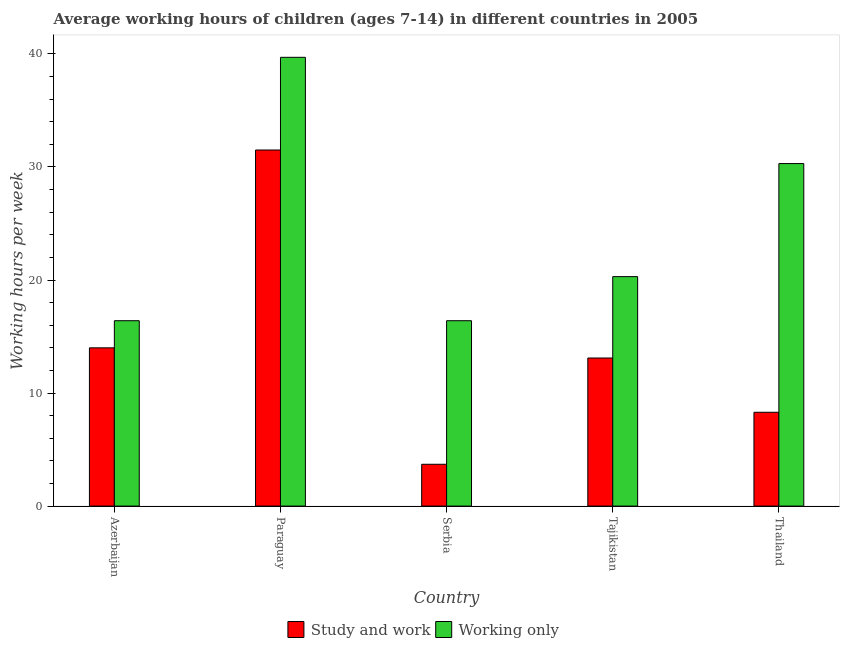Are the number of bars on each tick of the X-axis equal?
Give a very brief answer. Yes. What is the label of the 2nd group of bars from the left?
Make the answer very short. Paraguay. In how many cases, is the number of bars for a given country not equal to the number of legend labels?
Your answer should be compact. 0. What is the average working hour of children involved in study and work in Thailand?
Offer a terse response. 8.3. Across all countries, what is the maximum average working hour of children involved in only work?
Keep it short and to the point. 39.7. Across all countries, what is the minimum average working hour of children involved in only work?
Your response must be concise. 16.4. In which country was the average working hour of children involved in study and work maximum?
Offer a terse response. Paraguay. In which country was the average working hour of children involved in study and work minimum?
Provide a short and direct response. Serbia. What is the total average working hour of children involved in study and work in the graph?
Give a very brief answer. 70.6. What is the difference between the average working hour of children involved in only work in Paraguay and that in Tajikistan?
Your answer should be compact. 19.4. What is the difference between the average working hour of children involved in only work in Thailand and the average working hour of children involved in study and work in Serbia?
Keep it short and to the point. 26.6. What is the average average working hour of children involved in study and work per country?
Ensure brevity in your answer.  14.12. What is the difference between the average working hour of children involved in study and work and average working hour of children involved in only work in Thailand?
Make the answer very short. -22. What is the ratio of the average working hour of children involved in study and work in Tajikistan to that in Thailand?
Ensure brevity in your answer.  1.58. Is the average working hour of children involved in study and work in Serbia less than that in Tajikistan?
Provide a short and direct response. Yes. What is the difference between the highest and the second highest average working hour of children involved in study and work?
Your response must be concise. 17.5. What is the difference between the highest and the lowest average working hour of children involved in only work?
Provide a short and direct response. 23.3. In how many countries, is the average working hour of children involved in study and work greater than the average average working hour of children involved in study and work taken over all countries?
Give a very brief answer. 1. What does the 1st bar from the left in Azerbaijan represents?
Ensure brevity in your answer.  Study and work. What does the 1st bar from the right in Thailand represents?
Provide a short and direct response. Working only. What is the difference between two consecutive major ticks on the Y-axis?
Your answer should be very brief. 10. Does the graph contain grids?
Your answer should be very brief. No. How are the legend labels stacked?
Provide a succinct answer. Horizontal. What is the title of the graph?
Give a very brief answer. Average working hours of children (ages 7-14) in different countries in 2005. What is the label or title of the Y-axis?
Offer a terse response. Working hours per week. What is the Working hours per week in Study and work in Paraguay?
Make the answer very short. 31.5. What is the Working hours per week in Working only in Paraguay?
Provide a short and direct response. 39.7. What is the Working hours per week in Study and work in Serbia?
Make the answer very short. 3.7. What is the Working hours per week in Working only in Tajikistan?
Keep it short and to the point. 20.3. What is the Working hours per week of Study and work in Thailand?
Make the answer very short. 8.3. What is the Working hours per week of Working only in Thailand?
Your answer should be compact. 30.3. Across all countries, what is the maximum Working hours per week of Study and work?
Ensure brevity in your answer.  31.5. Across all countries, what is the maximum Working hours per week of Working only?
Give a very brief answer. 39.7. Across all countries, what is the minimum Working hours per week in Working only?
Make the answer very short. 16.4. What is the total Working hours per week in Study and work in the graph?
Give a very brief answer. 70.6. What is the total Working hours per week in Working only in the graph?
Provide a succinct answer. 123.1. What is the difference between the Working hours per week of Study and work in Azerbaijan and that in Paraguay?
Keep it short and to the point. -17.5. What is the difference between the Working hours per week in Working only in Azerbaijan and that in Paraguay?
Provide a short and direct response. -23.3. What is the difference between the Working hours per week of Study and work in Azerbaijan and that in Serbia?
Your response must be concise. 10.3. What is the difference between the Working hours per week in Working only in Azerbaijan and that in Serbia?
Keep it short and to the point. 0. What is the difference between the Working hours per week of Study and work in Azerbaijan and that in Tajikistan?
Offer a very short reply. 0.9. What is the difference between the Working hours per week of Working only in Azerbaijan and that in Tajikistan?
Your answer should be compact. -3.9. What is the difference between the Working hours per week of Study and work in Azerbaijan and that in Thailand?
Your response must be concise. 5.7. What is the difference between the Working hours per week in Working only in Azerbaijan and that in Thailand?
Keep it short and to the point. -13.9. What is the difference between the Working hours per week of Study and work in Paraguay and that in Serbia?
Offer a very short reply. 27.8. What is the difference between the Working hours per week of Working only in Paraguay and that in Serbia?
Make the answer very short. 23.3. What is the difference between the Working hours per week of Study and work in Paraguay and that in Tajikistan?
Make the answer very short. 18.4. What is the difference between the Working hours per week in Study and work in Paraguay and that in Thailand?
Make the answer very short. 23.2. What is the difference between the Working hours per week in Working only in Paraguay and that in Thailand?
Ensure brevity in your answer.  9.4. What is the difference between the Working hours per week in Study and work in Serbia and that in Tajikistan?
Provide a succinct answer. -9.4. What is the difference between the Working hours per week of Working only in Serbia and that in Tajikistan?
Offer a very short reply. -3.9. What is the difference between the Working hours per week of Study and work in Serbia and that in Thailand?
Offer a very short reply. -4.6. What is the difference between the Working hours per week of Working only in Serbia and that in Thailand?
Ensure brevity in your answer.  -13.9. What is the difference between the Working hours per week in Study and work in Tajikistan and that in Thailand?
Your answer should be very brief. 4.8. What is the difference between the Working hours per week in Working only in Tajikistan and that in Thailand?
Give a very brief answer. -10. What is the difference between the Working hours per week of Study and work in Azerbaijan and the Working hours per week of Working only in Paraguay?
Your answer should be very brief. -25.7. What is the difference between the Working hours per week of Study and work in Azerbaijan and the Working hours per week of Working only in Serbia?
Provide a succinct answer. -2.4. What is the difference between the Working hours per week in Study and work in Azerbaijan and the Working hours per week in Working only in Thailand?
Provide a short and direct response. -16.3. What is the difference between the Working hours per week of Study and work in Paraguay and the Working hours per week of Working only in Serbia?
Make the answer very short. 15.1. What is the difference between the Working hours per week in Study and work in Paraguay and the Working hours per week in Working only in Thailand?
Your response must be concise. 1.2. What is the difference between the Working hours per week of Study and work in Serbia and the Working hours per week of Working only in Tajikistan?
Ensure brevity in your answer.  -16.6. What is the difference between the Working hours per week of Study and work in Serbia and the Working hours per week of Working only in Thailand?
Offer a terse response. -26.6. What is the difference between the Working hours per week of Study and work in Tajikistan and the Working hours per week of Working only in Thailand?
Your answer should be compact. -17.2. What is the average Working hours per week of Study and work per country?
Your answer should be very brief. 14.12. What is the average Working hours per week in Working only per country?
Provide a short and direct response. 24.62. What is the difference between the Working hours per week of Study and work and Working hours per week of Working only in Azerbaijan?
Keep it short and to the point. -2.4. What is the difference between the Working hours per week in Study and work and Working hours per week in Working only in Paraguay?
Your answer should be very brief. -8.2. What is the difference between the Working hours per week in Study and work and Working hours per week in Working only in Tajikistan?
Provide a short and direct response. -7.2. What is the ratio of the Working hours per week in Study and work in Azerbaijan to that in Paraguay?
Offer a very short reply. 0.44. What is the ratio of the Working hours per week of Working only in Azerbaijan to that in Paraguay?
Offer a very short reply. 0.41. What is the ratio of the Working hours per week of Study and work in Azerbaijan to that in Serbia?
Offer a very short reply. 3.78. What is the ratio of the Working hours per week of Study and work in Azerbaijan to that in Tajikistan?
Provide a succinct answer. 1.07. What is the ratio of the Working hours per week in Working only in Azerbaijan to that in Tajikistan?
Provide a short and direct response. 0.81. What is the ratio of the Working hours per week in Study and work in Azerbaijan to that in Thailand?
Provide a short and direct response. 1.69. What is the ratio of the Working hours per week in Working only in Azerbaijan to that in Thailand?
Ensure brevity in your answer.  0.54. What is the ratio of the Working hours per week of Study and work in Paraguay to that in Serbia?
Your answer should be very brief. 8.51. What is the ratio of the Working hours per week of Working only in Paraguay to that in Serbia?
Your response must be concise. 2.42. What is the ratio of the Working hours per week of Study and work in Paraguay to that in Tajikistan?
Keep it short and to the point. 2.4. What is the ratio of the Working hours per week in Working only in Paraguay to that in Tajikistan?
Make the answer very short. 1.96. What is the ratio of the Working hours per week in Study and work in Paraguay to that in Thailand?
Keep it short and to the point. 3.8. What is the ratio of the Working hours per week in Working only in Paraguay to that in Thailand?
Provide a succinct answer. 1.31. What is the ratio of the Working hours per week in Study and work in Serbia to that in Tajikistan?
Your answer should be compact. 0.28. What is the ratio of the Working hours per week of Working only in Serbia to that in Tajikistan?
Your answer should be compact. 0.81. What is the ratio of the Working hours per week of Study and work in Serbia to that in Thailand?
Ensure brevity in your answer.  0.45. What is the ratio of the Working hours per week in Working only in Serbia to that in Thailand?
Ensure brevity in your answer.  0.54. What is the ratio of the Working hours per week of Study and work in Tajikistan to that in Thailand?
Your answer should be compact. 1.58. What is the ratio of the Working hours per week of Working only in Tajikistan to that in Thailand?
Offer a terse response. 0.67. What is the difference between the highest and the second highest Working hours per week in Study and work?
Give a very brief answer. 17.5. What is the difference between the highest and the second highest Working hours per week of Working only?
Give a very brief answer. 9.4. What is the difference between the highest and the lowest Working hours per week of Study and work?
Offer a terse response. 27.8. What is the difference between the highest and the lowest Working hours per week of Working only?
Keep it short and to the point. 23.3. 